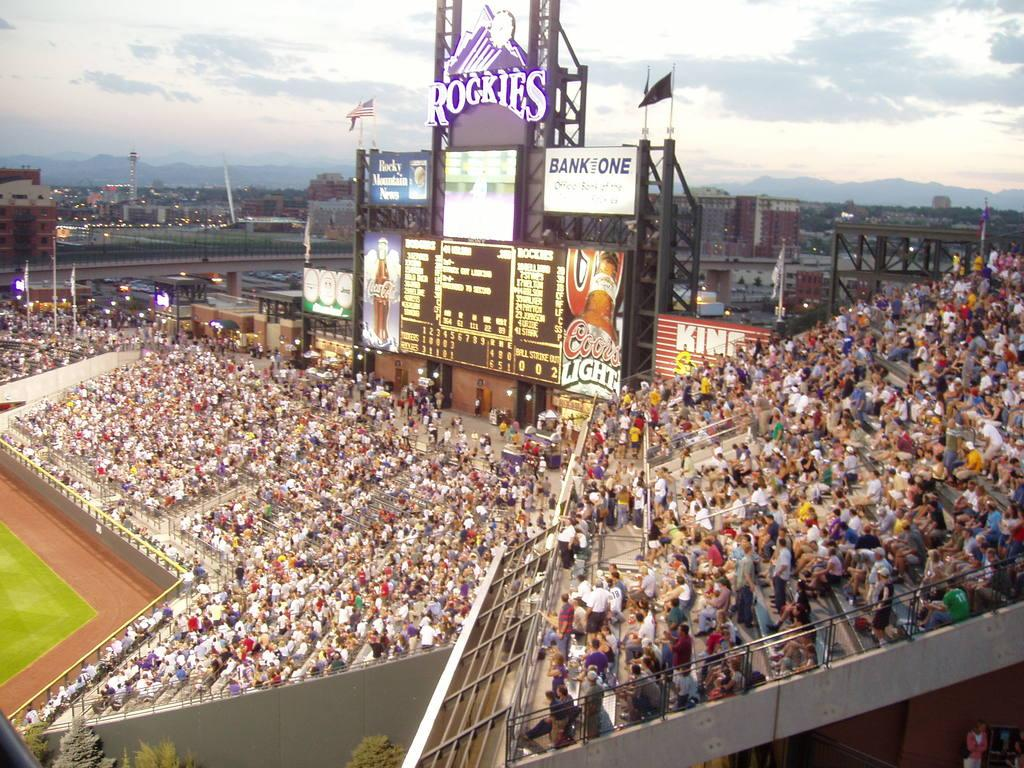Provide a one-sentence caption for the provided image. People attending a baseball game at the Rockies stadium. 